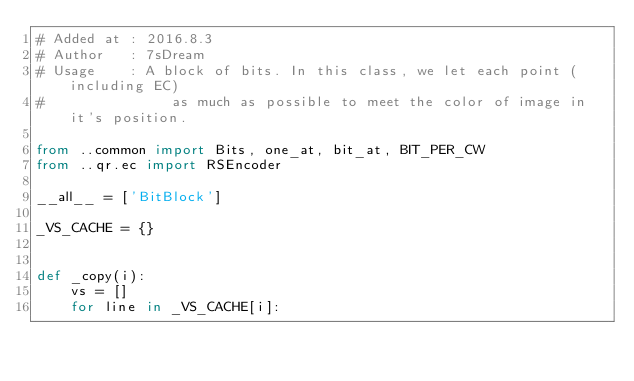<code> <loc_0><loc_0><loc_500><loc_500><_Python_># Added at : 2016.8.3
# Author   : 7sDream
# Usage    : A block of bits. In this class, we let each point (including EC)
#               as much as possible to meet the color of image in it's position.

from ..common import Bits, one_at, bit_at, BIT_PER_CW
from ..qr.ec import RSEncoder

__all__ = ['BitBlock']

_VS_CACHE = {}


def _copy(i):
    vs = []
    for line in _VS_CACHE[i]:</code> 